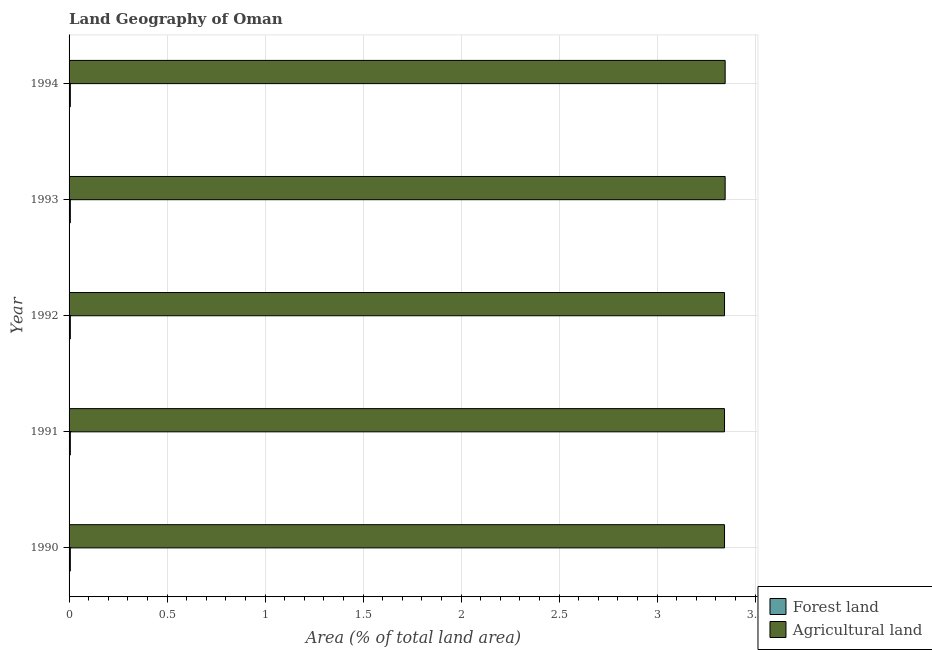How many groups of bars are there?
Offer a very short reply. 5. What is the label of the 4th group of bars from the top?
Offer a very short reply. 1991. What is the percentage of land area under forests in 1994?
Provide a short and direct response. 0.01. Across all years, what is the maximum percentage of land area under forests?
Provide a short and direct response. 0.01. Across all years, what is the minimum percentage of land area under agriculture?
Provide a short and direct response. 3.34. In which year was the percentage of land area under agriculture maximum?
Your answer should be very brief. 1993. In which year was the percentage of land area under forests minimum?
Offer a terse response. 1990. What is the total percentage of land area under agriculture in the graph?
Your response must be concise. 16.73. What is the difference between the percentage of land area under agriculture in 1990 and that in 1992?
Give a very brief answer. 0. What is the difference between the percentage of land area under forests in 1991 and the percentage of land area under agriculture in 1994?
Give a very brief answer. -3.34. What is the average percentage of land area under forests per year?
Offer a very short reply. 0.01. In the year 1992, what is the difference between the percentage of land area under agriculture and percentage of land area under forests?
Offer a very short reply. 3.34. In how many years, is the percentage of land area under forests greater than 0.8 %?
Provide a short and direct response. 0. Is the percentage of land area under forests in 1990 less than that in 1994?
Your answer should be compact. No. Is the difference between the percentage of land area under forests in 1990 and 1993 greater than the difference between the percentage of land area under agriculture in 1990 and 1993?
Offer a terse response. Yes. What is the difference between the highest and the second highest percentage of land area under forests?
Ensure brevity in your answer.  0. What is the difference between the highest and the lowest percentage of land area under agriculture?
Make the answer very short. 0. What does the 1st bar from the top in 1990 represents?
Your answer should be very brief. Agricultural land. What does the 2nd bar from the bottom in 1994 represents?
Offer a very short reply. Agricultural land. Are all the bars in the graph horizontal?
Provide a short and direct response. Yes. What is the difference between two consecutive major ticks on the X-axis?
Keep it short and to the point. 0.5. Are the values on the major ticks of X-axis written in scientific E-notation?
Ensure brevity in your answer.  No. Does the graph contain any zero values?
Keep it short and to the point. No. Does the graph contain grids?
Provide a short and direct response. Yes. Where does the legend appear in the graph?
Provide a short and direct response. Bottom right. What is the title of the graph?
Offer a very short reply. Land Geography of Oman. Does "Non-residents" appear as one of the legend labels in the graph?
Your answer should be compact. No. What is the label or title of the X-axis?
Give a very brief answer. Area (% of total land area). What is the Area (% of total land area) of Forest land in 1990?
Make the answer very short. 0.01. What is the Area (% of total land area) in Agricultural land in 1990?
Your answer should be very brief. 3.34. What is the Area (% of total land area) in Forest land in 1991?
Ensure brevity in your answer.  0.01. What is the Area (% of total land area) of Agricultural land in 1991?
Keep it short and to the point. 3.34. What is the Area (% of total land area) of Forest land in 1992?
Provide a short and direct response. 0.01. What is the Area (% of total land area) in Agricultural land in 1992?
Keep it short and to the point. 3.34. What is the Area (% of total land area) in Forest land in 1993?
Keep it short and to the point. 0.01. What is the Area (% of total land area) in Agricultural land in 1993?
Your response must be concise. 3.35. What is the Area (% of total land area) of Forest land in 1994?
Keep it short and to the point. 0.01. What is the Area (% of total land area) of Agricultural land in 1994?
Your response must be concise. 3.35. Across all years, what is the maximum Area (% of total land area) in Forest land?
Ensure brevity in your answer.  0.01. Across all years, what is the maximum Area (% of total land area) of Agricultural land?
Your answer should be very brief. 3.35. Across all years, what is the minimum Area (% of total land area) in Forest land?
Make the answer very short. 0.01. Across all years, what is the minimum Area (% of total land area) in Agricultural land?
Provide a succinct answer. 3.34. What is the total Area (% of total land area) in Forest land in the graph?
Make the answer very short. 0.03. What is the total Area (% of total land area) of Agricultural land in the graph?
Ensure brevity in your answer.  16.73. What is the difference between the Area (% of total land area) of Agricultural land in 1990 and that in 1991?
Your answer should be very brief. 0. What is the difference between the Area (% of total land area) of Forest land in 1990 and that in 1993?
Keep it short and to the point. 0. What is the difference between the Area (% of total land area) of Agricultural land in 1990 and that in 1993?
Your response must be concise. -0. What is the difference between the Area (% of total land area) in Agricultural land in 1990 and that in 1994?
Ensure brevity in your answer.  -0. What is the difference between the Area (% of total land area) of Forest land in 1991 and that in 1992?
Keep it short and to the point. 0. What is the difference between the Area (% of total land area) in Forest land in 1991 and that in 1993?
Offer a very short reply. 0. What is the difference between the Area (% of total land area) of Agricultural land in 1991 and that in 1993?
Your answer should be compact. -0. What is the difference between the Area (% of total land area) of Agricultural land in 1991 and that in 1994?
Provide a short and direct response. -0. What is the difference between the Area (% of total land area) of Agricultural land in 1992 and that in 1993?
Offer a terse response. -0. What is the difference between the Area (% of total land area) of Agricultural land in 1992 and that in 1994?
Your answer should be very brief. -0. What is the difference between the Area (% of total land area) in Forest land in 1990 and the Area (% of total land area) in Agricultural land in 1991?
Provide a succinct answer. -3.34. What is the difference between the Area (% of total land area) in Forest land in 1990 and the Area (% of total land area) in Agricultural land in 1992?
Keep it short and to the point. -3.34. What is the difference between the Area (% of total land area) in Forest land in 1990 and the Area (% of total land area) in Agricultural land in 1993?
Provide a succinct answer. -3.34. What is the difference between the Area (% of total land area) in Forest land in 1990 and the Area (% of total land area) in Agricultural land in 1994?
Ensure brevity in your answer.  -3.34. What is the difference between the Area (% of total land area) of Forest land in 1991 and the Area (% of total land area) of Agricultural land in 1992?
Offer a terse response. -3.34. What is the difference between the Area (% of total land area) in Forest land in 1991 and the Area (% of total land area) in Agricultural land in 1993?
Offer a very short reply. -3.34. What is the difference between the Area (% of total land area) in Forest land in 1991 and the Area (% of total land area) in Agricultural land in 1994?
Your response must be concise. -3.34. What is the difference between the Area (% of total land area) in Forest land in 1992 and the Area (% of total land area) in Agricultural land in 1993?
Keep it short and to the point. -3.34. What is the difference between the Area (% of total land area) in Forest land in 1992 and the Area (% of total land area) in Agricultural land in 1994?
Provide a short and direct response. -3.34. What is the difference between the Area (% of total land area) of Forest land in 1993 and the Area (% of total land area) of Agricultural land in 1994?
Provide a short and direct response. -3.34. What is the average Area (% of total land area) of Forest land per year?
Ensure brevity in your answer.  0.01. What is the average Area (% of total land area) of Agricultural land per year?
Provide a succinct answer. 3.35. In the year 1990, what is the difference between the Area (% of total land area) in Forest land and Area (% of total land area) in Agricultural land?
Provide a succinct answer. -3.34. In the year 1991, what is the difference between the Area (% of total land area) in Forest land and Area (% of total land area) in Agricultural land?
Provide a short and direct response. -3.34. In the year 1992, what is the difference between the Area (% of total land area) in Forest land and Area (% of total land area) in Agricultural land?
Provide a succinct answer. -3.34. In the year 1993, what is the difference between the Area (% of total land area) in Forest land and Area (% of total land area) in Agricultural land?
Provide a succinct answer. -3.34. In the year 1994, what is the difference between the Area (% of total land area) of Forest land and Area (% of total land area) of Agricultural land?
Make the answer very short. -3.34. What is the ratio of the Area (% of total land area) of Agricultural land in 1990 to that in 1991?
Make the answer very short. 1. What is the ratio of the Area (% of total land area) in Forest land in 1990 to that in 1993?
Make the answer very short. 1. What is the ratio of the Area (% of total land area) of Forest land in 1990 to that in 1994?
Provide a short and direct response. 1. What is the ratio of the Area (% of total land area) in Forest land in 1991 to that in 1993?
Provide a short and direct response. 1. What is the ratio of the Area (% of total land area) in Agricultural land in 1991 to that in 1994?
Make the answer very short. 1. What is the ratio of the Area (% of total land area) in Agricultural land in 1992 to that in 1993?
Your response must be concise. 1. What is the ratio of the Area (% of total land area) in Forest land in 1992 to that in 1994?
Keep it short and to the point. 1. What is the ratio of the Area (% of total land area) of Agricultural land in 1992 to that in 1994?
Ensure brevity in your answer.  1. What is the difference between the highest and the second highest Area (% of total land area) of Forest land?
Offer a very short reply. 0. What is the difference between the highest and the lowest Area (% of total land area) in Agricultural land?
Keep it short and to the point. 0. 